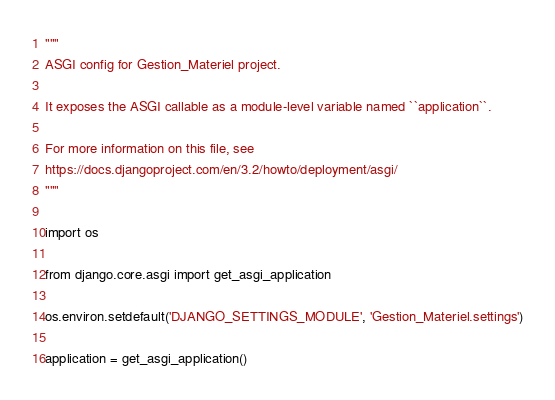Convert code to text. <code><loc_0><loc_0><loc_500><loc_500><_Python_>"""
ASGI config for Gestion_Materiel project.

It exposes the ASGI callable as a module-level variable named ``application``.

For more information on this file, see
https://docs.djangoproject.com/en/3.2/howto/deployment/asgi/
"""

import os

from django.core.asgi import get_asgi_application

os.environ.setdefault('DJANGO_SETTINGS_MODULE', 'Gestion_Materiel.settings')

application = get_asgi_application()
</code> 